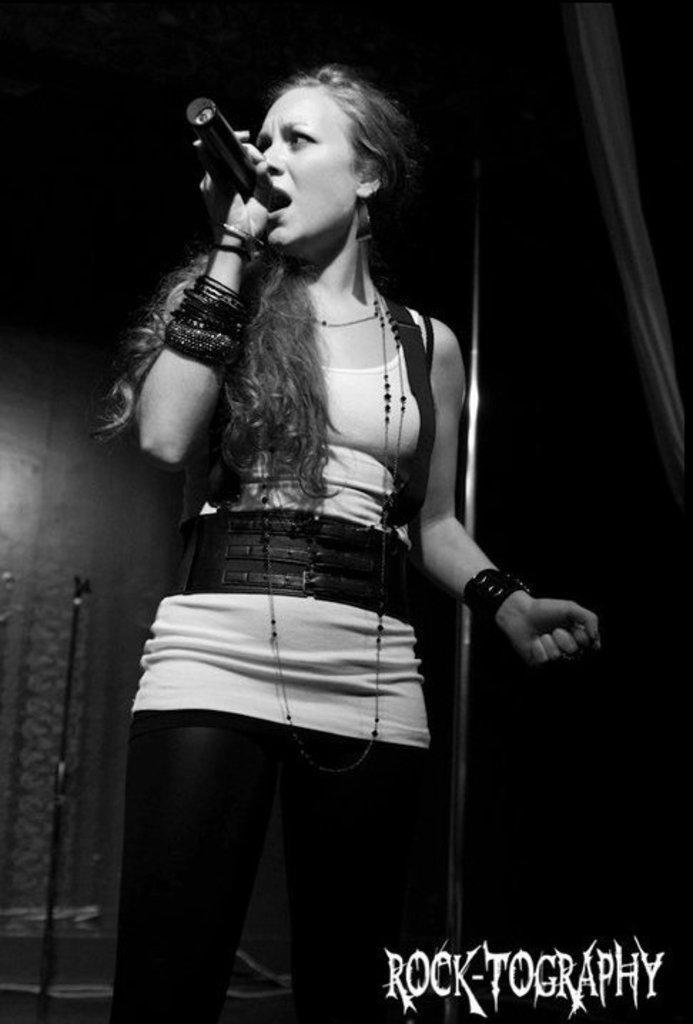How would you summarize this image in a sentence or two? As we can see in the image there is a woman singing on mic. 